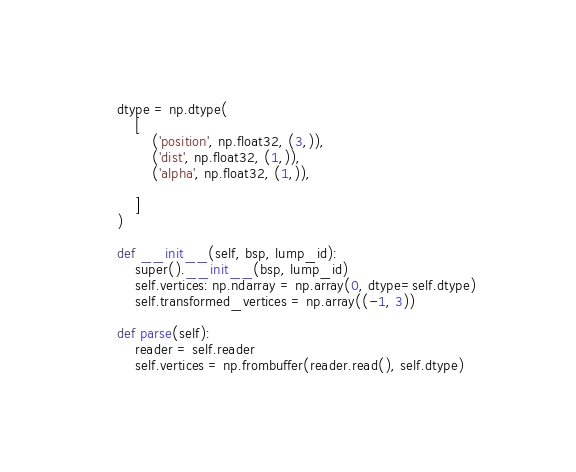<code> <loc_0><loc_0><loc_500><loc_500><_Python_>    dtype = np.dtype(
        [
            ('position', np.float32, (3,)),
            ('dist', np.float32, (1,)),
            ('alpha', np.float32, (1,)),

        ]
    )

    def __init__(self, bsp, lump_id):
        super().__init__(bsp, lump_id)
        self.vertices: np.ndarray = np.array(0, dtype=self.dtype)
        self.transformed_vertices = np.array((-1, 3))

    def parse(self):
        reader = self.reader
        self.vertices = np.frombuffer(reader.read(), self.dtype)
</code> 